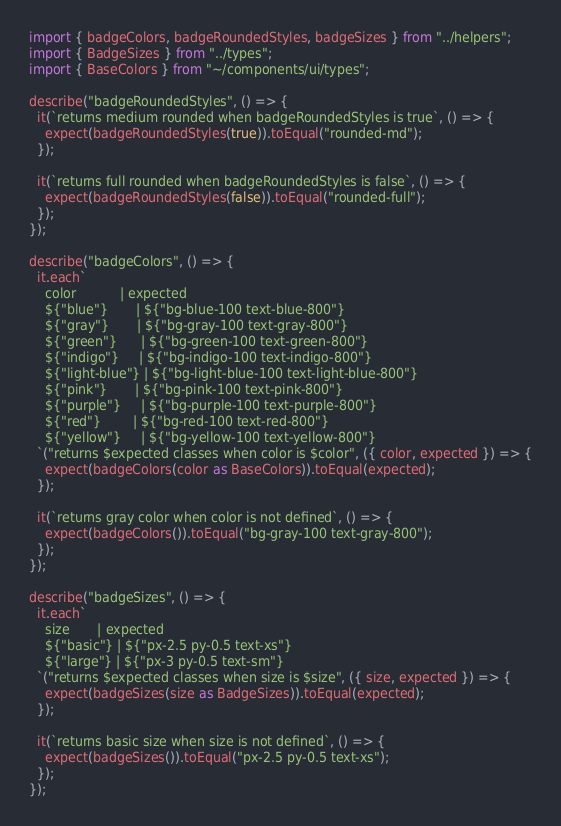Convert code to text. <code><loc_0><loc_0><loc_500><loc_500><_TypeScript_>import { badgeColors, badgeRoundedStyles, badgeSizes } from "../helpers";
import { BadgeSizes } from "../types";
import { BaseColors } from "~/components/ui/types";

describe("badgeRoundedStyles", () => {
  it(`returns medium rounded when badgeRoundedStyles is true`, () => {
    expect(badgeRoundedStyles(true)).toEqual("rounded-md");
  });

  it(`returns full rounded when badgeRoundedStyles is false`, () => {
    expect(badgeRoundedStyles(false)).toEqual("rounded-full");
  });
});

describe("badgeColors", () => {
  it.each`
    color           | expected
    ${"blue"}       | ${"bg-blue-100 text-blue-800"}
    ${"gray"}       | ${"bg-gray-100 text-gray-800"}
    ${"green"}      | ${"bg-green-100 text-green-800"}
    ${"indigo"}     | ${"bg-indigo-100 text-indigo-800"}
    ${"light-blue"} | ${"bg-light-blue-100 text-light-blue-800"}
    ${"pink"}       | ${"bg-pink-100 text-pink-800"}
    ${"purple"}     | ${"bg-purple-100 text-purple-800"}
    ${"red"}        | ${"bg-red-100 text-red-800"}
    ${"yellow"}     | ${"bg-yellow-100 text-yellow-800"}
  `("returns $expected classes when color is $color", ({ color, expected }) => {
    expect(badgeColors(color as BaseColors)).toEqual(expected);
  });

  it(`returns gray color when color is not defined`, () => {
    expect(badgeColors()).toEqual("bg-gray-100 text-gray-800");
  });
});

describe("badgeSizes", () => {
  it.each`
    size       | expected
    ${"basic"} | ${"px-2.5 py-0.5 text-xs"}
    ${"large"} | ${"px-3 py-0.5 text-sm"}
  `("returns $expected classes when size is $size", ({ size, expected }) => {
    expect(badgeSizes(size as BadgeSizes)).toEqual(expected);
  });

  it(`returns basic size when size is not defined`, () => {
    expect(badgeSizes()).toEqual("px-2.5 py-0.5 text-xs");
  });
});
</code> 